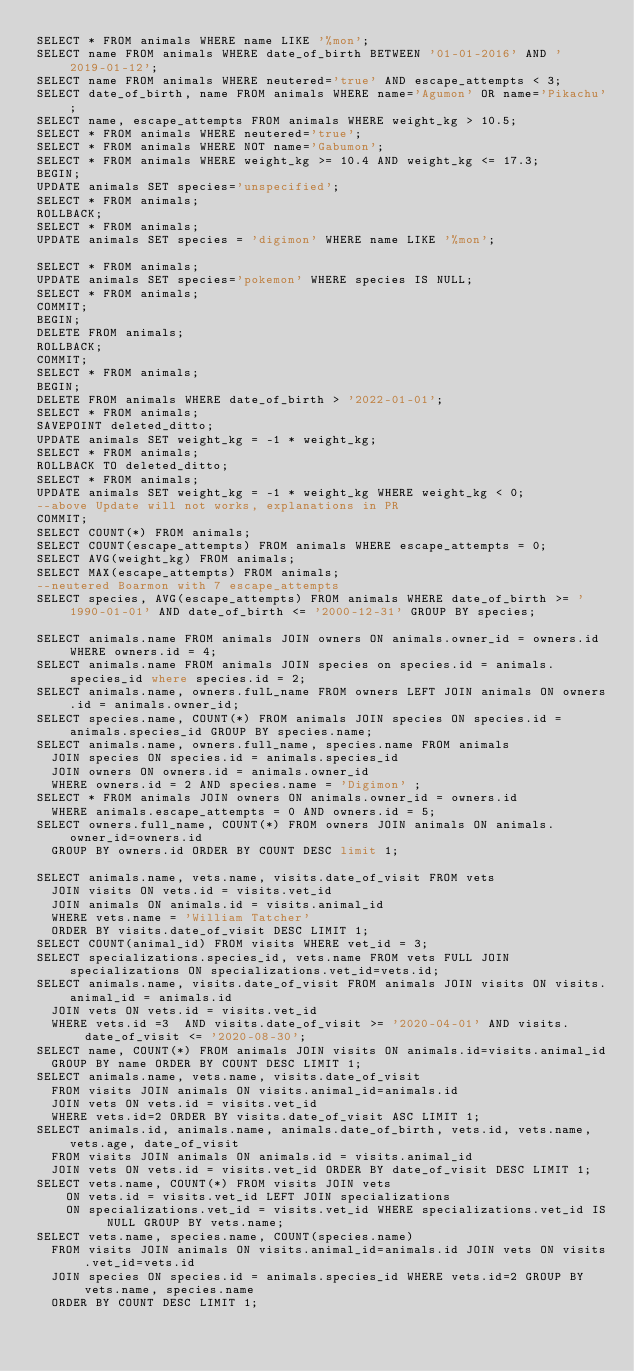Convert code to text. <code><loc_0><loc_0><loc_500><loc_500><_SQL_>SELECT * FROM animals WHERE name LIKE '%mon';
SELECT name FROM animals WHERE date_of_birth BETWEEN '01-01-2016' AND '2019-01-12';
SELECT name FROM animals WHERE neutered='true' AND escape_attempts < 3;
SELECT date_of_birth, name FROM animals WHERE name='Agumon' OR name='Pikachu';
SELECT name, escape_attempts FROM animals WHERE weight_kg > 10.5;
SELECT * FROM animals WHERE neutered='true';
SELECT * FROM animals WHERE NOT name='Gabumon';
SELECT * FROM animals WHERE weight_kg >= 10.4 AND weight_kg <= 17.3;
BEGIN;
UPDATE animals SET species='unspecified';
SELECT * FROM animals;
ROLLBACK;
SELECT * FROM animals;
UPDATE animals SET species = 'digimon' WHERE name LIKE '%mon';

SELECT * FROM animals;
UPDATE animals SET species='pokemon' WHERE species IS NULL;
SELECT * FROM animals;
COMMIT;
BEGIN;
DELETE FROM animals;
ROLLBACK;
COMMIT; 
SELECT * FROM animals;
BEGIN;
DELETE FROM animals WHERE date_of_birth > '2022-01-01';
SELECT * FROM animals;
SAVEPOINT deleted_ditto;
UPDATE animals SET weight_kg = -1 * weight_kg;
SELECT * FROM animals;
ROLLBACK TO deleted_ditto;
SELECT * FROM animals;
UPDATE animals SET weight_kg = -1 * weight_kg WHERE weight_kg < 0;
--above Update will not works, explanations in PR
COMMIT;
SELECT COUNT(*) FROM animals;
SELECT COUNT(escape_attempts) FROM animals WHERE escape_attempts = 0;
SELECT AVG(weight_kg) FROM animals;
SELECT MAX(escape_attempts) FROM animals;
--neutered Boarmon with 7 escape_attempts
SELECT species, AVG(escape_attempts) FROM animals WHERE date_of_birth >= '1990-01-01' AND date_of_birth <= '2000-12-31' GROUP BY species;

SELECT animals.name FROM animals JOIN owners ON animals.owner_id = owners.id WHERE owners.id = 4;
SELECT animals.name FROM animals JOIN species on species.id = animals.species_id where species.id = 2;
SELECT animals.name, owners.fulL_name FROM owners LEFT JOIN animals ON owners.id = animals.owner_id;
SELECT species.name, COUNT(*) FROM animals JOIN species ON species.id = animals.species_id GROUP BY species.name;
SELECT animals.name, owners.full_name, species.name FROM animals
  JOIN species ON species.id = animals.species_id
  JOIN owners ON owners.id = animals.owner_id
  WHERE owners.id = 2 AND species.name = 'Digimon' ;
SELECT * FROM animals JOIN owners ON animals.owner_id = owners.id 
  WHERE animals.escape_attempts = 0 AND owners.id = 5;
SELECT owners.full_name, COUNT(*) FROM owners JOIN animals ON animals.owner_id=owners.id
  GROUP BY owners.id ORDER BY COUNT DESC limit 1;

SELECT animals.name, vets.name, visits.date_of_visit FROM vets
  JOIN visits ON vets.id = visits.vet_id
  JOIN animals ON animals.id = visits.animal_id
  WHERE vets.name = 'William Tatcher'
  ORDER BY visits.date_of_visit DESC LIMIT 1;
SELECT COUNT(animal_id) FROM visits WHERE vet_id = 3;
SELECT specializations.species_id, vets.name FROM vets FULL JOIN specializations ON specializations.vet_id=vets.id;
SELECT animals.name, visits.date_of_visit FROM animals JOIN visits ON visits.animal_id = animals.id
  JOIN vets ON vets.id = visits.vet_id
  WHERE vets.id =3  AND visits.date_of_visit >= '2020-04-01' AND visits.date_of_visit <= '2020-08-30';
SELECT name, COUNT(*) FROM animals JOIN visits ON animals.id=visits.animal_id
  GROUP BY name ORDER BY COUNT DESC LIMIT 1;
SELECT animals.name, vets.name, visits.date_of_visit
  FROM visits JOIN animals ON visits.animal_id=animals.id
  JOIN vets ON vets.id = visits.vet_id
  WHERE vets.id=2 ORDER BY visits.date_of_visit ASC LIMIT 1;
SELECT animals.id, animals.name, animals.date_of_birth, vets.id, vets.name, vets.age, date_of_visit
  FROM visits JOIN animals ON animals.id = visits.animal_id
  JOIN vets ON vets.id = visits.vet_id ORDER BY date_of_visit DESC LIMIT 1;
SELECT vets.name, COUNT(*) FROM visits JOIN vets 
    ON vets.id = visits.vet_id LEFT JOIN specializations 
    ON specializations.vet_id = visits.vet_id WHERE specializations.vet_id IS NULL GROUP BY vets.name;
SELECT vets.name, species.name, COUNT(species.name)
  FROM visits JOIN animals ON visits.animal_id=animals.id JOIN vets ON visits.vet_id=vets.id
  JOIN species ON species.id = animals.species_id WHERE vets.id=2 GROUP BY vets.name, species.name
  ORDER BY COUNT DESC LIMIT 1;


</code> 